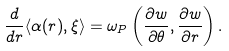<formula> <loc_0><loc_0><loc_500><loc_500>\frac { d } { d r } \langle \alpha ( r ) , \xi \rangle = \omega _ { P } \left ( \frac { \partial w } { \partial \theta } , \frac { \partial w } { \partial r } \right ) .</formula> 